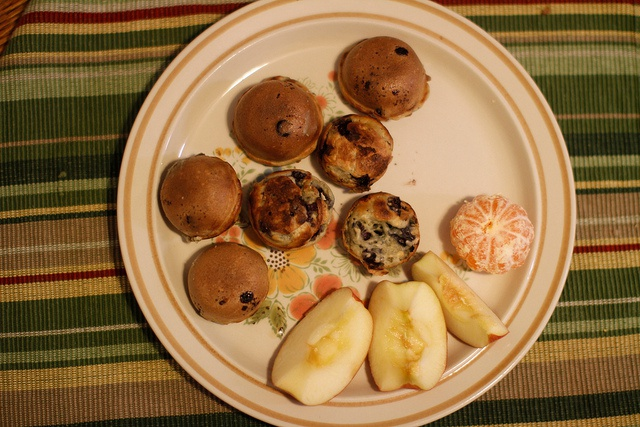Describe the objects in this image and their specific colors. I can see apple in maroon, tan, and orange tones, apple in maroon, tan, and orange tones, donut in maroon and brown tones, orange in maroon, tan, and red tones, and donut in maroon, brown, and black tones in this image. 